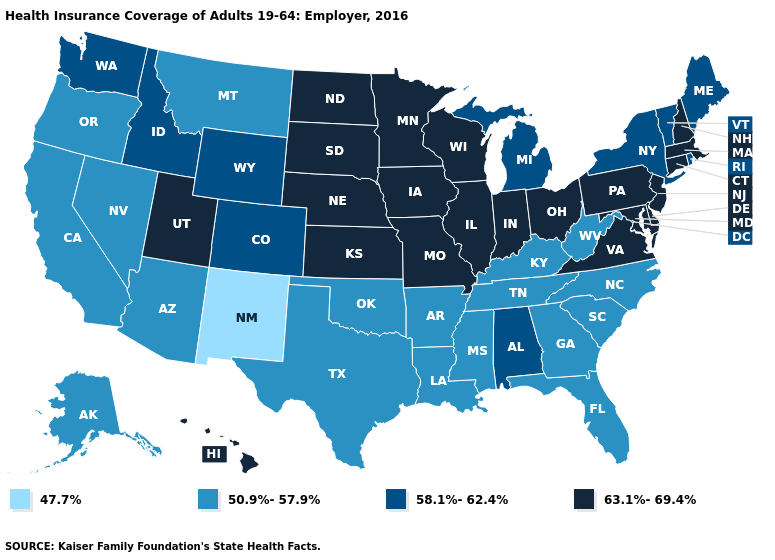Does Colorado have a lower value than Kansas?
Quick response, please. Yes. Name the states that have a value in the range 50.9%-57.9%?
Quick response, please. Alaska, Arizona, Arkansas, California, Florida, Georgia, Kentucky, Louisiana, Mississippi, Montana, Nevada, North Carolina, Oklahoma, Oregon, South Carolina, Tennessee, Texas, West Virginia. Does Minnesota have the same value as South Dakota?
Answer briefly. Yes. Is the legend a continuous bar?
Concise answer only. No. What is the value of Iowa?
Keep it brief. 63.1%-69.4%. Does North Carolina have a higher value than New Mexico?
Write a very short answer. Yes. What is the lowest value in the South?
Short answer required. 50.9%-57.9%. Name the states that have a value in the range 63.1%-69.4%?
Give a very brief answer. Connecticut, Delaware, Hawaii, Illinois, Indiana, Iowa, Kansas, Maryland, Massachusetts, Minnesota, Missouri, Nebraska, New Hampshire, New Jersey, North Dakota, Ohio, Pennsylvania, South Dakota, Utah, Virginia, Wisconsin. Does the first symbol in the legend represent the smallest category?
Keep it brief. Yes. Which states hav the highest value in the Northeast?
Answer briefly. Connecticut, Massachusetts, New Hampshire, New Jersey, Pennsylvania. Does Virginia have the lowest value in the USA?
Give a very brief answer. No. Does Michigan have a higher value than Wyoming?
Concise answer only. No. Among the states that border Florida , does Alabama have the highest value?
Write a very short answer. Yes. Does Florida have the highest value in the USA?
Answer briefly. No. 